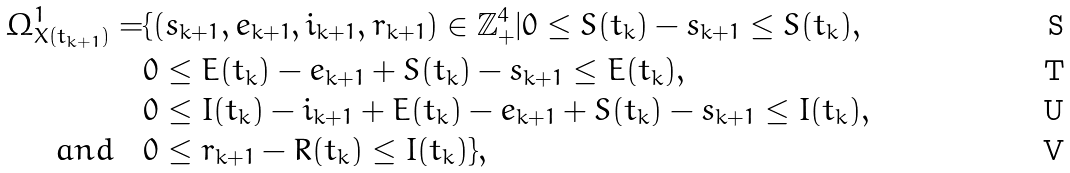<formula> <loc_0><loc_0><loc_500><loc_500>\Omega ^ { 1 } _ { X ( t _ { k + 1 } ) } = & \{ ( s _ { k + 1 } , e _ { k + 1 } , i _ { k + 1 } , r _ { k + 1 } ) \in \mathbb { Z } ^ { 4 } _ { + } | 0 \leq S ( t _ { k } ) - s _ { k + 1 } \leq S ( t _ { k } ) , \\ & 0 \leq E ( t _ { k } ) - e _ { k + 1 } + S ( t _ { k } ) - s _ { k + 1 } \leq E ( t _ { k } ) , \\ & 0 \leq I ( t _ { k } ) - i _ { k + 1 } + E ( t _ { k } ) - e _ { k + 1 } + S ( t _ { k } ) - s _ { k + 1 } \leq I ( t _ { k } ) , \\ \quad a n d \quad & 0 \leq r _ { k + 1 } - R ( t _ { k } ) \leq I ( t _ { k } ) \} ,</formula> 